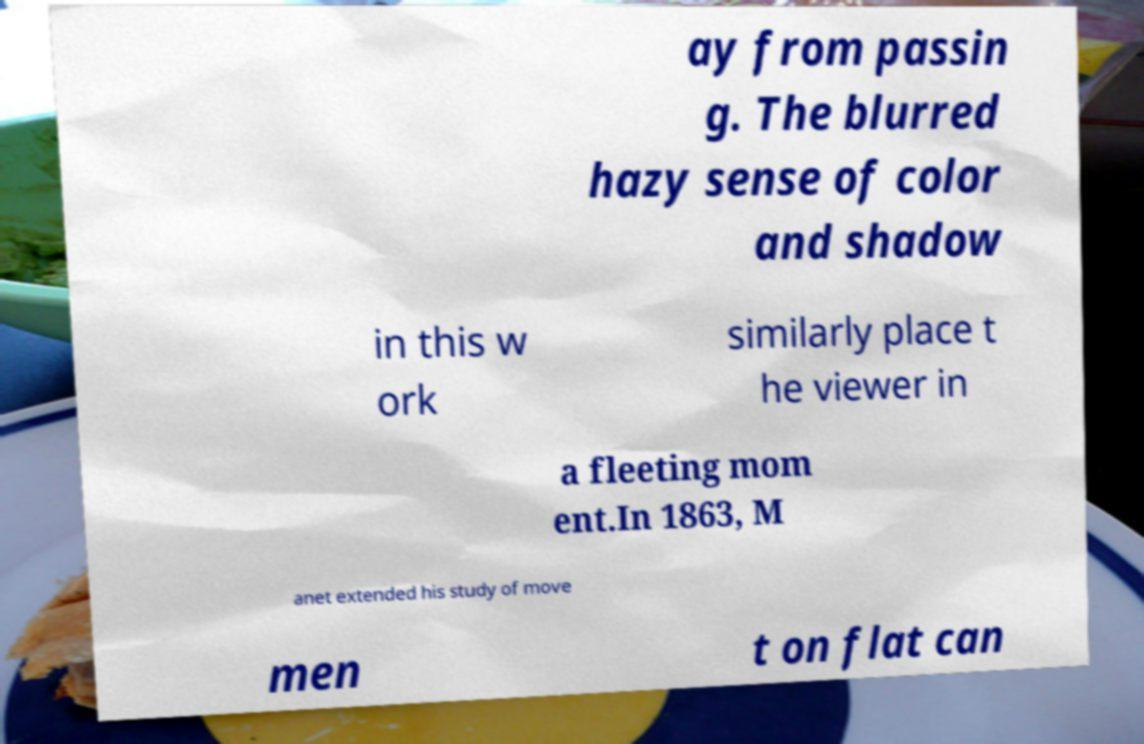Please identify and transcribe the text found in this image. ay from passin g. The blurred hazy sense of color and shadow in this w ork similarly place t he viewer in a fleeting mom ent.In 1863, M anet extended his study of move men t on flat can 